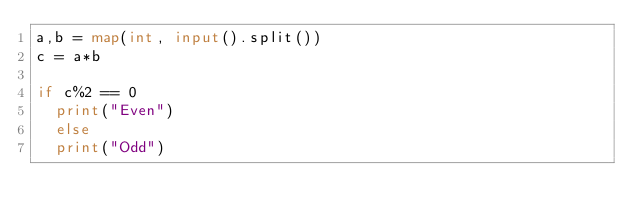<code> <loc_0><loc_0><loc_500><loc_500><_Python_>a,b = map(int, input().split())
c = a*b

if c%2 == 0
	print("Even")
  else
  print("Odd")
         </code> 